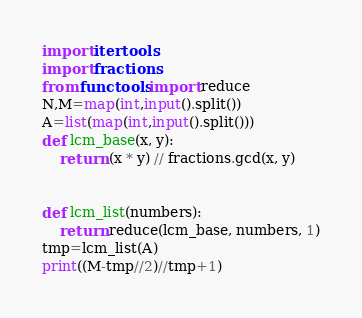Convert code to text. <code><loc_0><loc_0><loc_500><loc_500><_Python_>import itertools
import fractions
from functools import reduce
N,M=map(int,input().split())
A=list(map(int,input().split()))
def lcm_base(x, y):
    return (x * y) // fractions.gcd(x, y)


def lcm_list(numbers):
    return reduce(lcm_base, numbers, 1)
tmp=lcm_list(A)
print((M-tmp//2)//tmp+1)</code> 